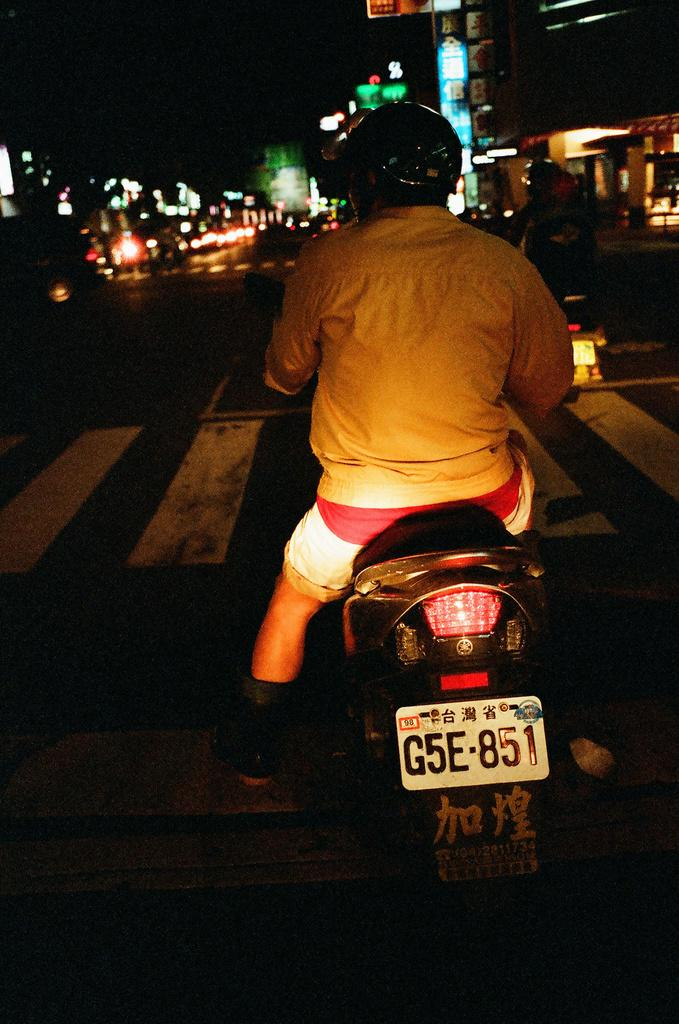What are the people in the image doing? The people in the image are sitting on bikes. What can be seen in the background of the image? There are lights, boards, and a building in the background of the image. What is visible at the bottom of the image? There is a road visible at the bottom of the image. What is the price of the boat in the image? There is no boat present in the image, so it is not possible to determine its price. 